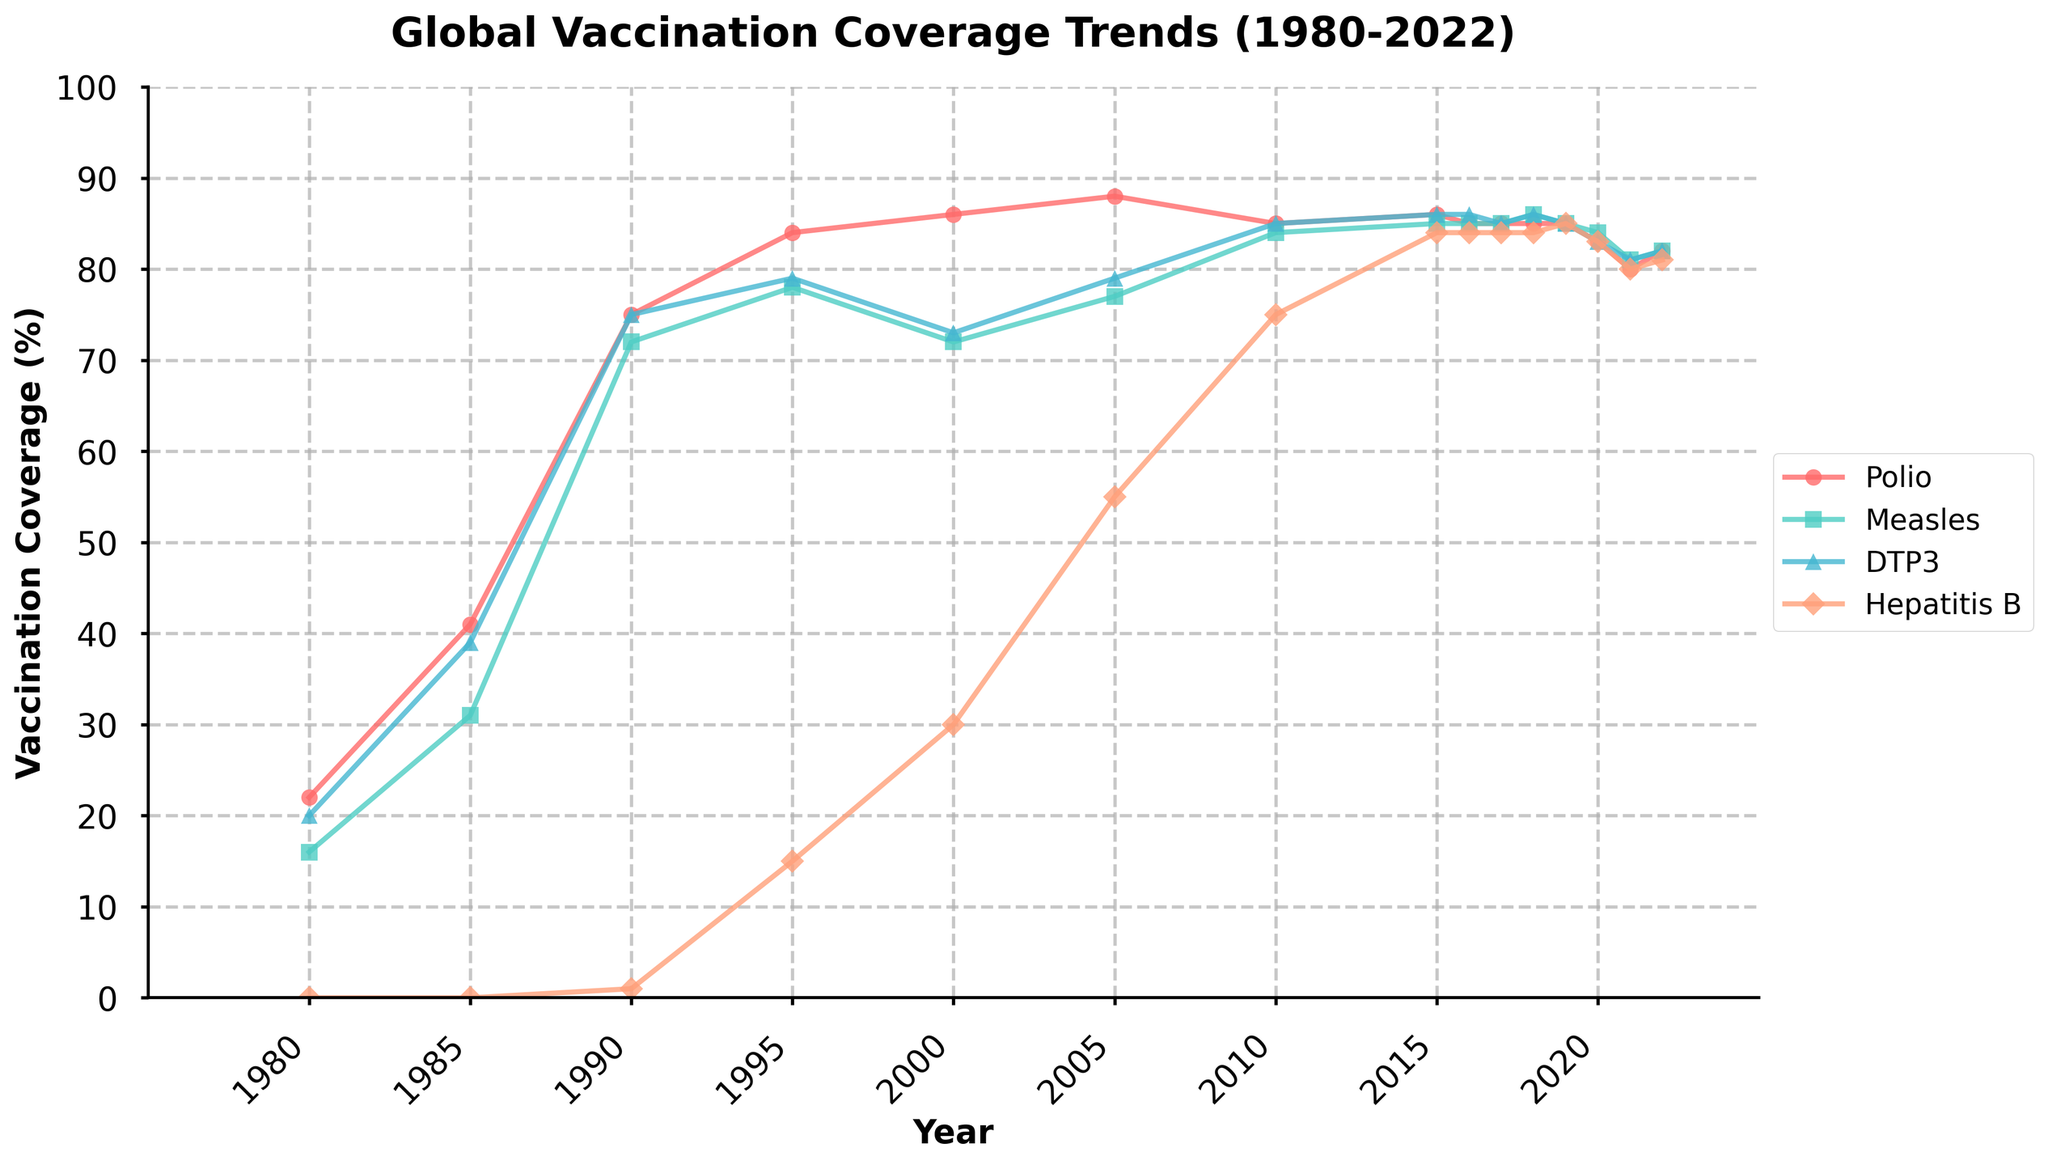Which disease saw the most significant increase in vaccination coverage from 1980 to 1990? To determine the disease with the most significant increase in vaccination coverage from 1980 to 1990, we calculate the difference for each disease: Polio (75-22 = 53), Measles (72-16 = 56), DTP3 (75-20 = 55), and Hepatitis B (1-0 = 1). The highest increase is seen in Measles.
Answer: Measles From 1995 to 2010, which disease had the most steady vaccination coverage trend? By examining the trend lines from 1995 to 2010 in the figure, we observe that both Polio and DTP3 have relatively stable trends, but DTP3's variations are smoother compared to Polio's.
Answer: DTP3 Compare the vaccination coverage of Measles and Hepatitis B in 2000. Which one was higher? Looking at the year 2000 on the x-axis and comparing the line heights for Measles and Hepatitis B, we see that Measles was at 72%, while Hepatitis B was at 30%.
Answer: Measles What is the overall trend observed in Polio vaccination coverage from 1980 to 2022? From 1980 to 1990, there is a sharp increase. From 1990 to 2005, there is a general upward trend, followed by a relatively stable period from 2005 to 2019. A slight decline is observed from 2019 to 2022.
Answer: Increasing, then stable, slight decline Between 2020 and 2022, which disease had the least reduction in vaccination coverage? Observing the differences in vaccination coverage percentages between 2020 and 2022 for each disease: Polio (83-82=1), Measles (84-82=2), DTP3 (83-82=1), and Hepatitis B (83-81=2). Both Polio and DTP3 had the least reduction, which is 1%.
Answer: Polio and DTP3 What color represents the DTP3 vaccination coverage in the figure? By referencing the legend on the figure, DTP3 is indicated by a cyan (light blue) color.
Answer: Cyan (light blue) In which year did all four diseases first exceed 80% vaccination coverage? By scanning through the data points for the year in which all disease lines are above the 80% level, we find that 2010 is the first year this happens.
Answer: 2010 How does the vaccination coverage for Hepatitis B change from 1990 to 1995? The figure shows that Hepatitis B went from 1% in 1990 to 15% in 1995, indicating a 14 percentage points increase.
Answer: Increased by 14 percentage points Compare the vaccination trends for Measles and Polio from 1985 to 2005. Which had a more consistent increase? By examining the lines from 1985 to 2005, Polio shows a more dramatic and continuous increase compared to Measles, which fluctuated more.
Answer: Polio What was the approximate average vaccination coverage of DTP3 between 2005 and 2015? The data points for DTP3 from 2005 to 2015 are: 79, 85, 86. The average is calculated as (79 + 85 + 86) / 3 = 83.3%.
Answer: 83.3% 